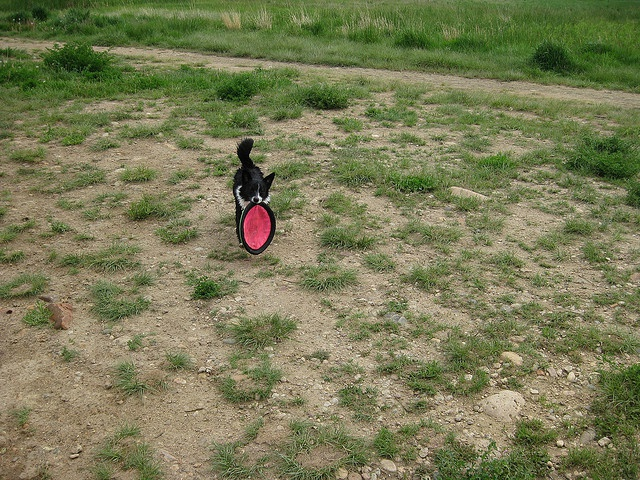Describe the objects in this image and their specific colors. I can see dog in darkgreen, black, salmon, and brown tones and frisbee in darkgreen, black, salmon, and brown tones in this image. 